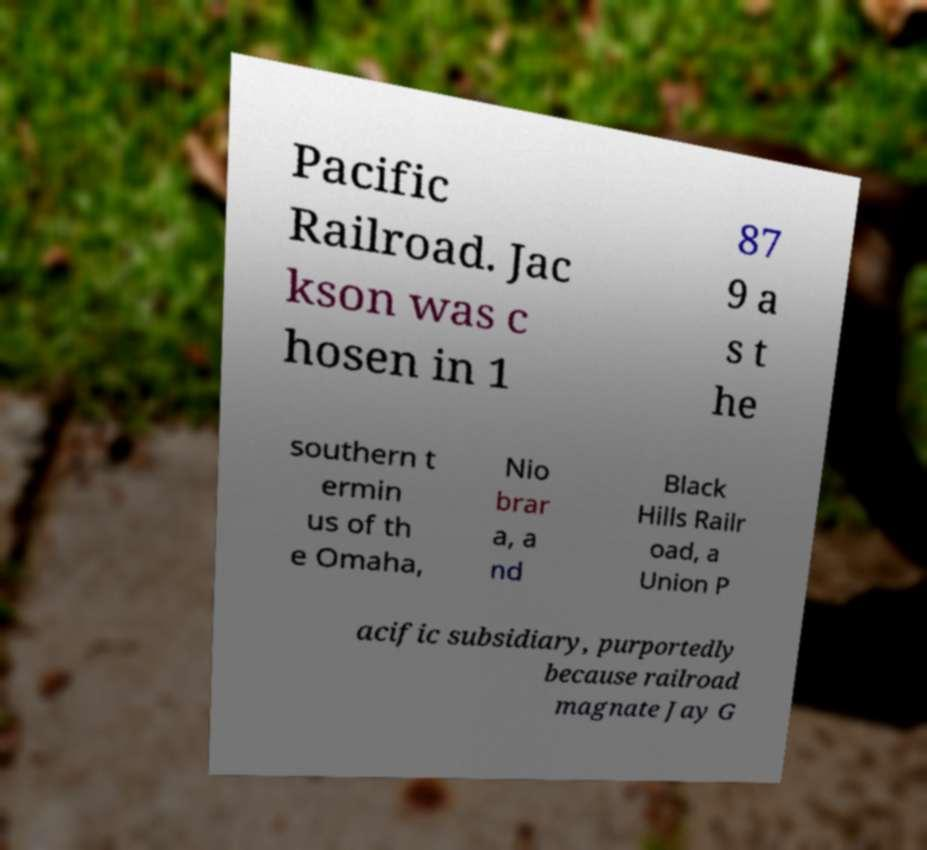What messages or text are displayed in this image? I need them in a readable, typed format. Pacific Railroad. Jac kson was c hosen in 1 87 9 a s t he southern t ermin us of th e Omaha, Nio brar a, a nd Black Hills Railr oad, a Union P acific subsidiary, purportedly because railroad magnate Jay G 